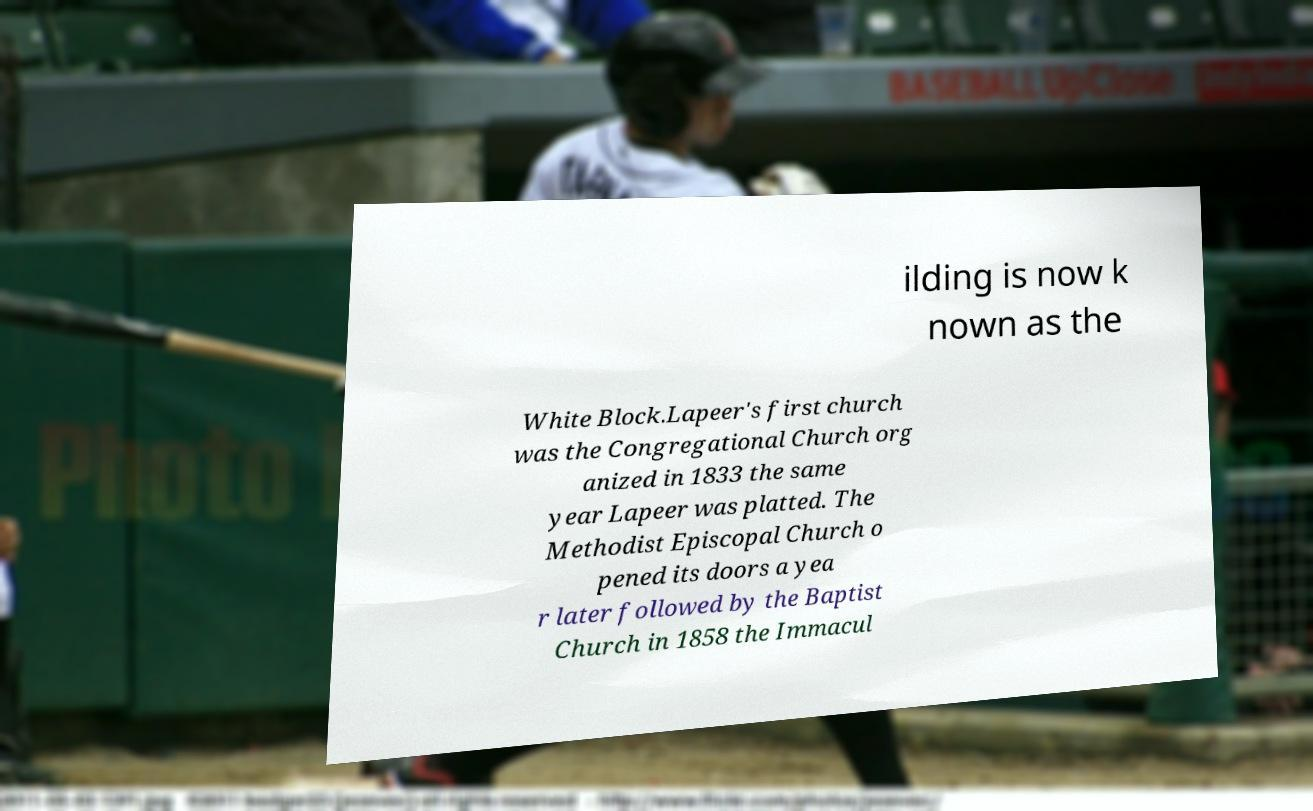Please read and relay the text visible in this image. What does it say? ilding is now k nown as the White Block.Lapeer's first church was the Congregational Church org anized in 1833 the same year Lapeer was platted. The Methodist Episcopal Church o pened its doors a yea r later followed by the Baptist Church in 1858 the Immacul 